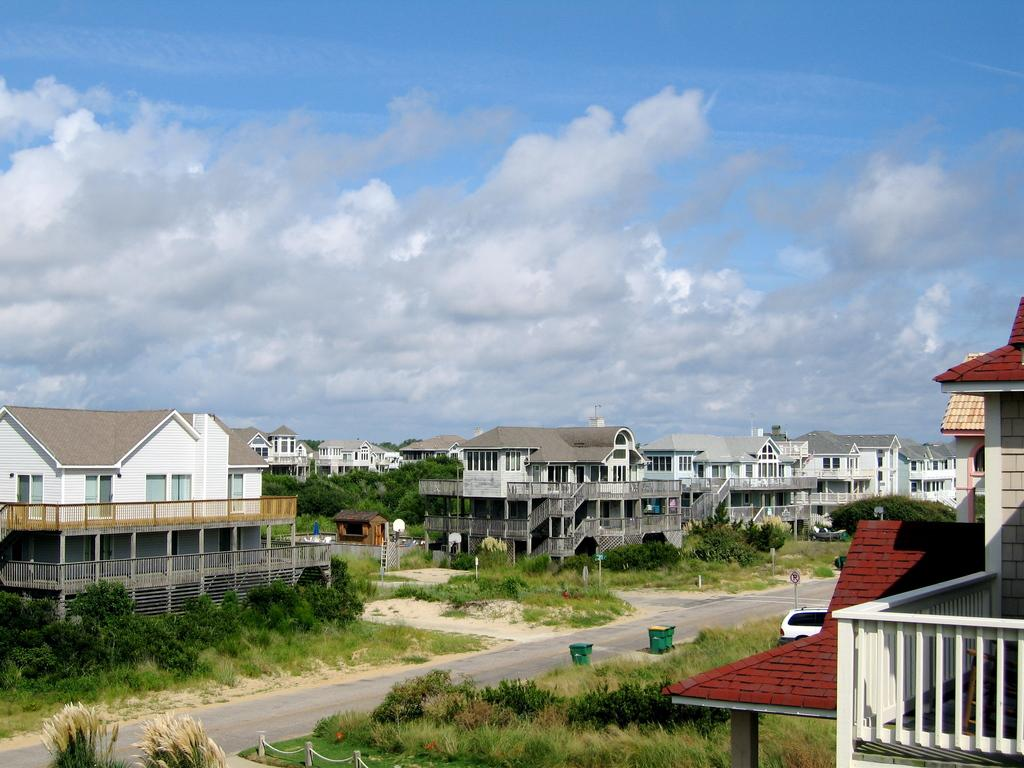What type of vegetation can be seen in the image? There are plants and grass in the image. What structure is attached to a pole in the image? There is a board attached to a pole in the image. What type of buildings are visible in the image? There are buildings in the image. What type of waste disposal containers are present on the road in the image? There are dustbins on the road in the image. What type of vehicle is visible in the image? There is a car in the image. What type of trees can be seen in the image? There are trees in the image. What part of the natural environment is visible in the background of the image? The sky is visible in the background of the image. What type of patch is visible on the car in the image? There is no patch visible on the car in the image. What type of motion is being performed by the trees in the image? The trees are not performing any motion in the image; they are stationary. What type of circle is present in the image? There is no circle present in the image. 